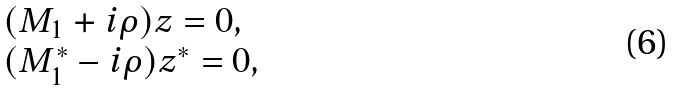Convert formula to latex. <formula><loc_0><loc_0><loc_500><loc_500>\begin{array} { l } ( M _ { 1 } + i \rho ) z = 0 , \\ ( M ^ { * } _ { 1 } - i \rho ) z ^ { * } = 0 , \end{array}</formula> 